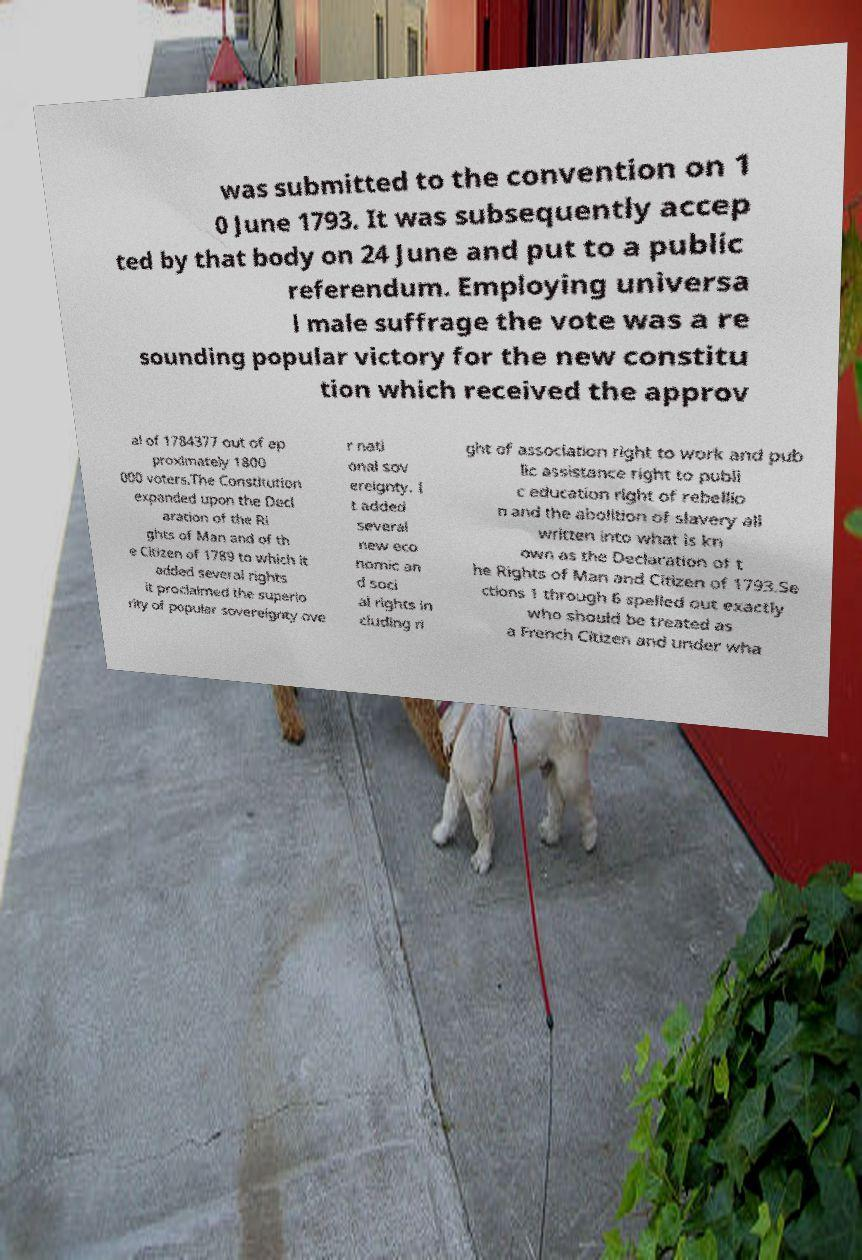There's text embedded in this image that I need extracted. Can you transcribe it verbatim? was submitted to the convention on 1 0 June 1793. It was subsequently accep ted by that body on 24 June and put to a public referendum. Employing universa l male suffrage the vote was a re sounding popular victory for the new constitu tion which received the approv al of 1784377 out of ap proximately 1800 000 voters.The Constitution expanded upon the Decl aration of the Ri ghts of Man and of th e Citizen of 1789 to which it added several rights it proclaimed the superio rity of popular sovereignty ove r nati onal sov ereignty. I t added several new eco nomic an d soci al rights in cluding ri ght of association right to work and pub lic assistance right to publi c education right of rebellio n and the abolition of slavery all written into what is kn own as the Declaration of t he Rights of Man and Citizen of 1793.Se ctions 1 through 6 spelled out exactly who should be treated as a French Citizen and under wha 